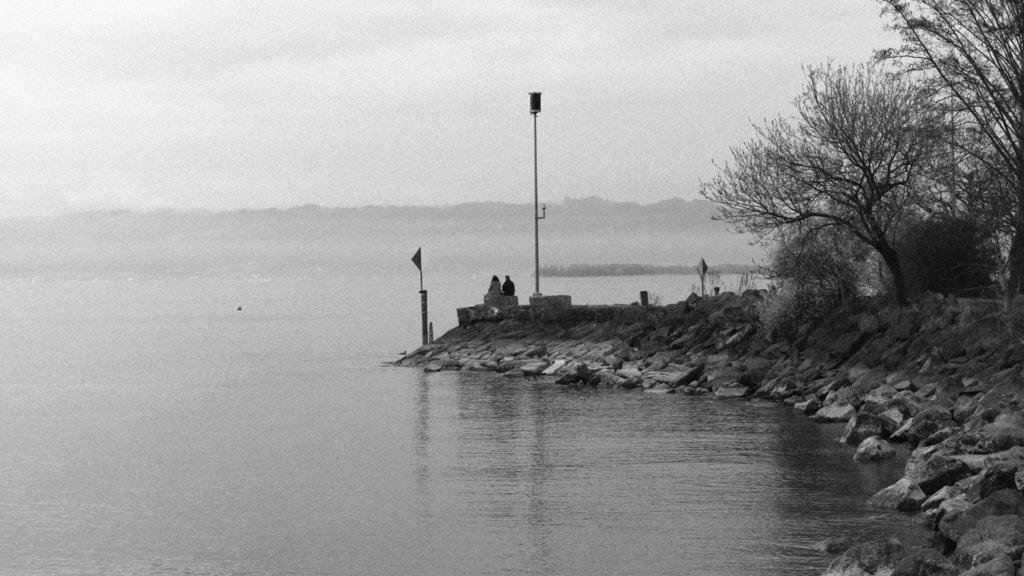How would you summarize this image in a sentence or two? In this image we can see water, rocks, trees, poles, these two people sitting on the rock, hills and sky in the background. 